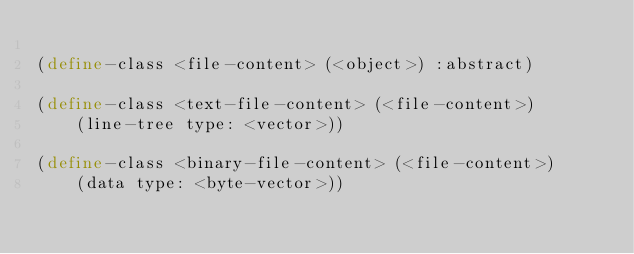Convert code to text. <code><loc_0><loc_0><loc_500><loc_500><_Scheme_>
(define-class <file-content> (<object>) :abstract)

(define-class <text-file-content> (<file-content>)
    (line-tree type: <vector>))

(define-class <binary-file-content> (<file-content>)
    (data type: <byte-vector>))
</code> 